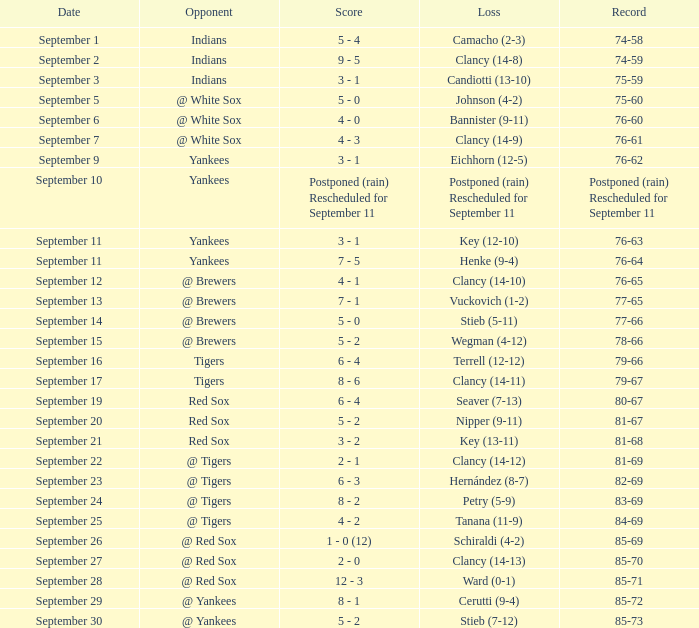Who was the Blue Jays opponent when their record was 84-69? @ Tigers. 